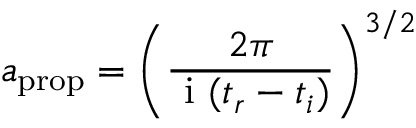Convert formula to latex. <formula><loc_0><loc_0><loc_500><loc_500>a _ { p r o p } = \left ( \frac { 2 \pi } { i ( t _ { r } - t _ { i } ) } \right ) ^ { 3 / 2 }</formula> 